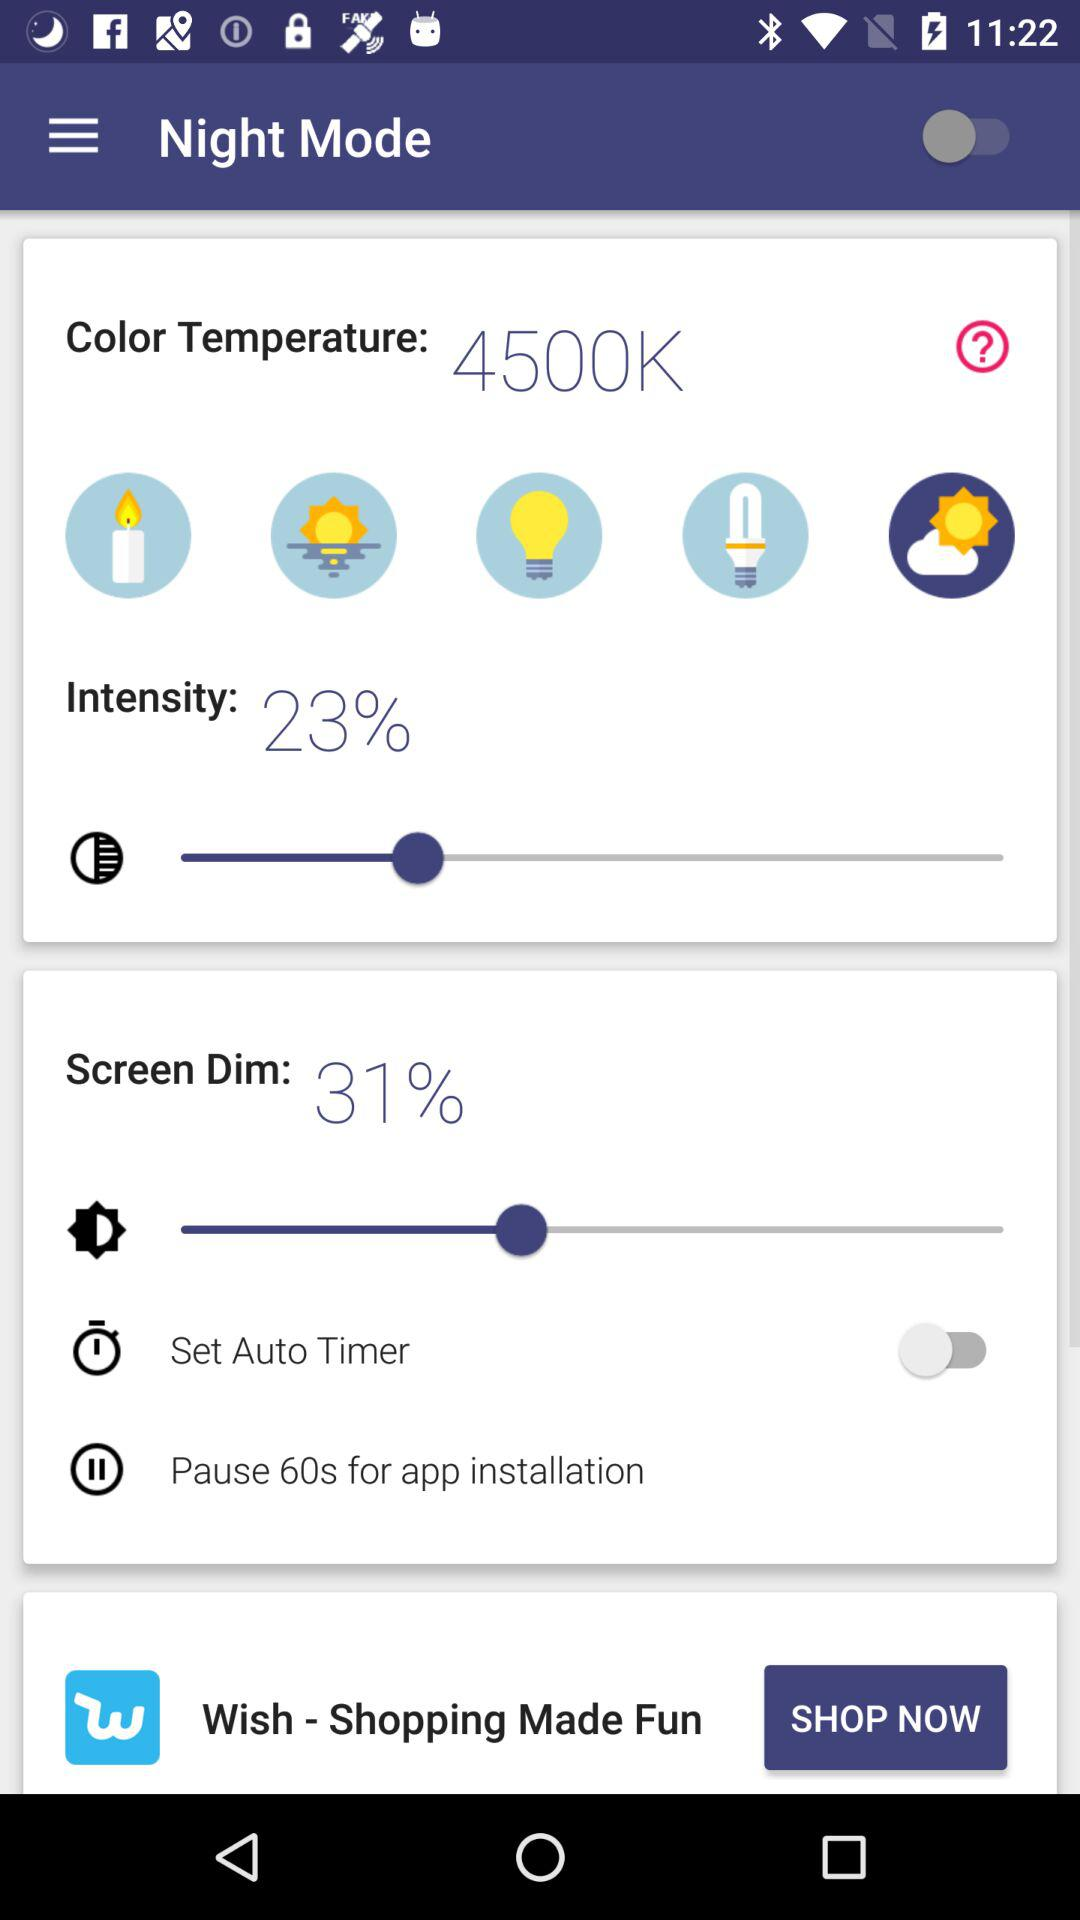How much is "Screen Dim"? "Screen Dim" is 31%. 